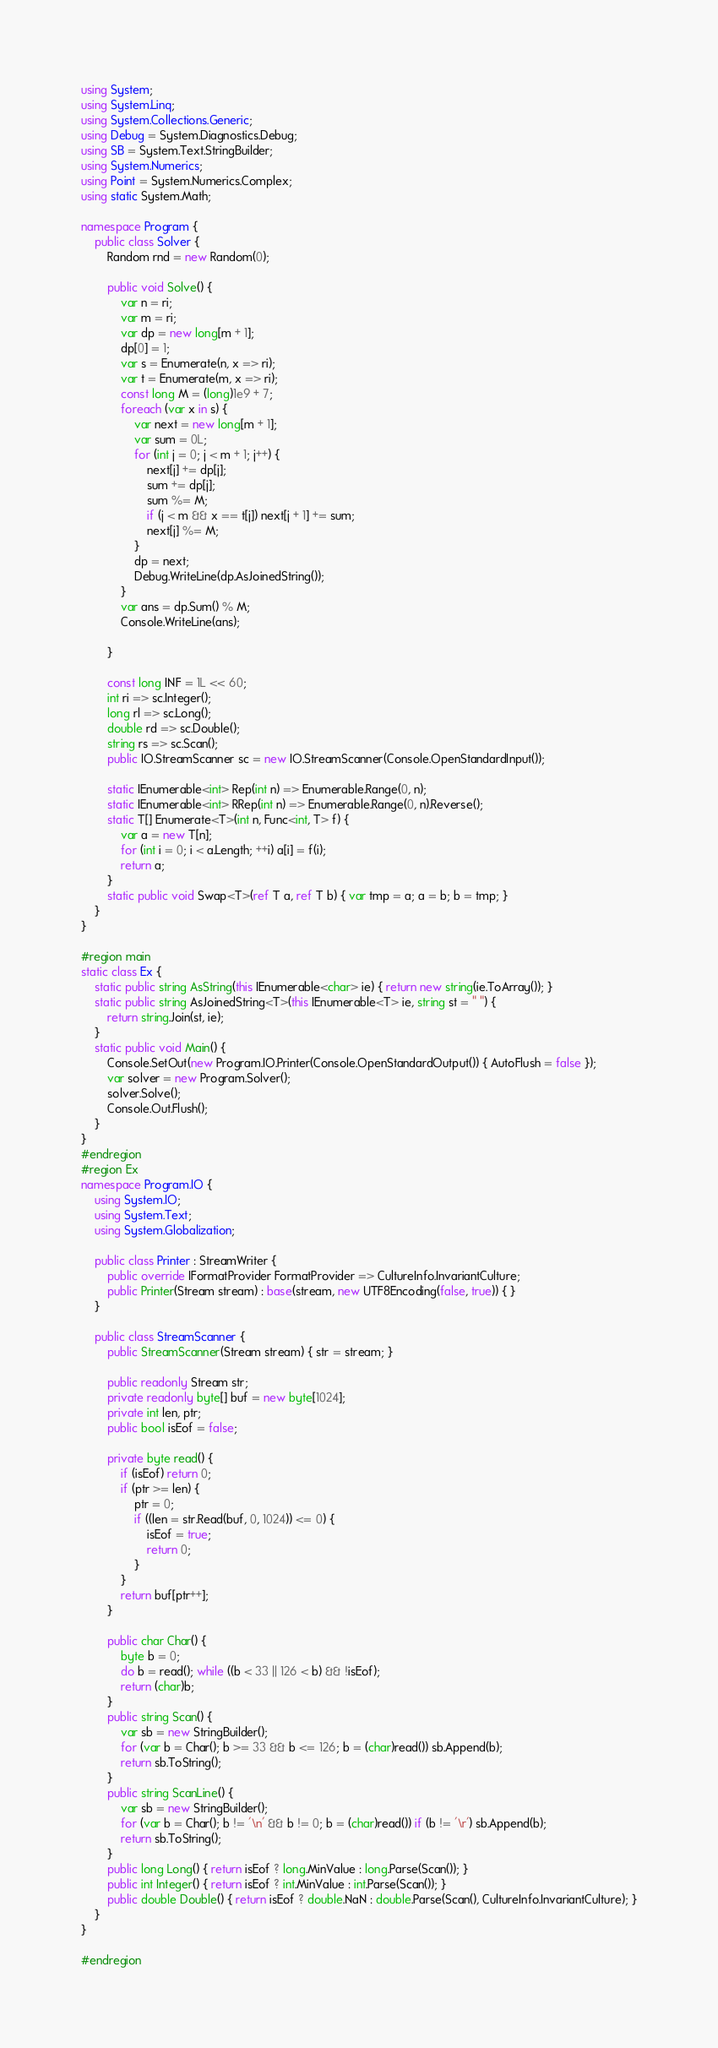<code> <loc_0><loc_0><loc_500><loc_500><_C#_>using System;
using System.Linq;
using System.Collections.Generic;
using Debug = System.Diagnostics.Debug;
using SB = System.Text.StringBuilder;
using System.Numerics;
using Point = System.Numerics.Complex;
using static System.Math;

namespace Program {
    public class Solver {
        Random rnd = new Random(0);

        public void Solve() {
            var n = ri;
            var m = ri;
            var dp = new long[m + 1];
            dp[0] = 1;
            var s = Enumerate(n, x => ri);
            var t = Enumerate(m, x => ri);
            const long M = (long)1e9 + 7;
            foreach (var x in s) {
                var next = new long[m + 1];
                var sum = 0L;
                for (int j = 0; j < m + 1; j++) {
                    next[j] += dp[j];
                    sum += dp[j];
                    sum %= M;
                    if (j < m && x == t[j]) next[j + 1] += sum;
                    next[j] %= M;
                }
                dp = next;
                Debug.WriteLine(dp.AsJoinedString());
            }
            var ans = dp.Sum() % M;
            Console.WriteLine(ans);

        }

        const long INF = 1L << 60;
        int ri => sc.Integer();
        long rl => sc.Long();
        double rd => sc.Double();
        string rs => sc.Scan();
        public IO.StreamScanner sc = new IO.StreamScanner(Console.OpenStandardInput());

        static IEnumerable<int> Rep(int n) => Enumerable.Range(0, n);
        static IEnumerable<int> RRep(int n) => Enumerable.Range(0, n).Reverse();
        static T[] Enumerate<T>(int n, Func<int, T> f) {
            var a = new T[n];
            for (int i = 0; i < a.Length; ++i) a[i] = f(i);
            return a;
        }
        static public void Swap<T>(ref T a, ref T b) { var tmp = a; a = b; b = tmp; }
    }
}

#region main
static class Ex {
    static public string AsString(this IEnumerable<char> ie) { return new string(ie.ToArray()); }
    static public string AsJoinedString<T>(this IEnumerable<T> ie, string st = " ") {
        return string.Join(st, ie);
    }
    static public void Main() {
        Console.SetOut(new Program.IO.Printer(Console.OpenStandardOutput()) { AutoFlush = false });
        var solver = new Program.Solver();
        solver.Solve();
        Console.Out.Flush();
    }
}
#endregion
#region Ex
namespace Program.IO {
    using System.IO;
    using System.Text;
    using System.Globalization;

    public class Printer : StreamWriter {
        public override IFormatProvider FormatProvider => CultureInfo.InvariantCulture;
        public Printer(Stream stream) : base(stream, new UTF8Encoding(false, true)) { }
    }

    public class StreamScanner {
        public StreamScanner(Stream stream) { str = stream; }

        public readonly Stream str;
        private readonly byte[] buf = new byte[1024];
        private int len, ptr;
        public bool isEof = false;

        private byte read() {
            if (isEof) return 0;
            if (ptr >= len) {
                ptr = 0;
                if ((len = str.Read(buf, 0, 1024)) <= 0) {
                    isEof = true;
                    return 0;
                }
            }
            return buf[ptr++];
        }

        public char Char() {
            byte b = 0;
            do b = read(); while ((b < 33 || 126 < b) && !isEof);
            return (char)b;
        }
        public string Scan() {
            var sb = new StringBuilder();
            for (var b = Char(); b >= 33 && b <= 126; b = (char)read()) sb.Append(b);
            return sb.ToString();
        }
        public string ScanLine() {
            var sb = new StringBuilder();
            for (var b = Char(); b != '\n' && b != 0; b = (char)read()) if (b != '\r') sb.Append(b);
            return sb.ToString();
        }
        public long Long() { return isEof ? long.MinValue : long.Parse(Scan()); }
        public int Integer() { return isEof ? int.MinValue : int.Parse(Scan()); }
        public double Double() { return isEof ? double.NaN : double.Parse(Scan(), CultureInfo.InvariantCulture); }
    }
}

#endregion

</code> 